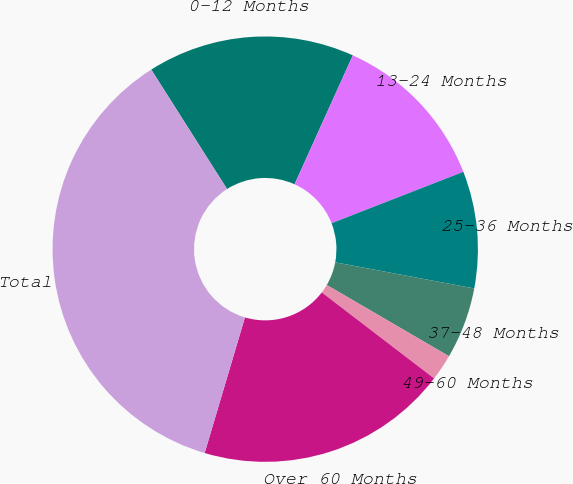<chart> <loc_0><loc_0><loc_500><loc_500><pie_chart><fcel>0-12 Months<fcel>13-24 Months<fcel>25-36 Months<fcel>37-48 Months<fcel>49-60 Months<fcel>Over 60 Months<fcel>Total<nl><fcel>15.76%<fcel>12.32%<fcel>8.88%<fcel>5.44%<fcel>2.0%<fcel>19.2%<fcel>36.4%<nl></chart> 